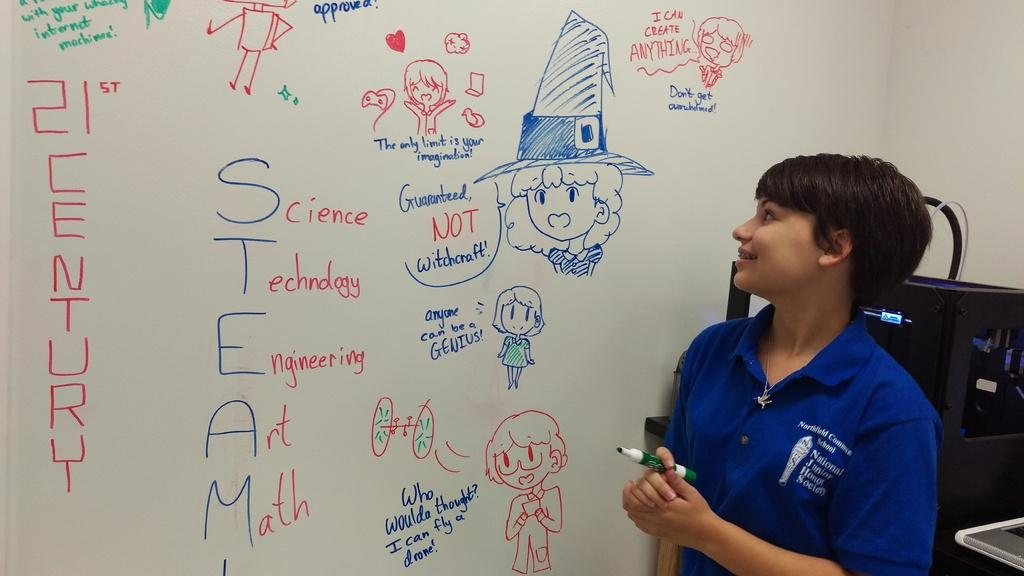<image>
Share a concise interpretation of the image provided. A woman stands in front of a white board that has the word science on it 